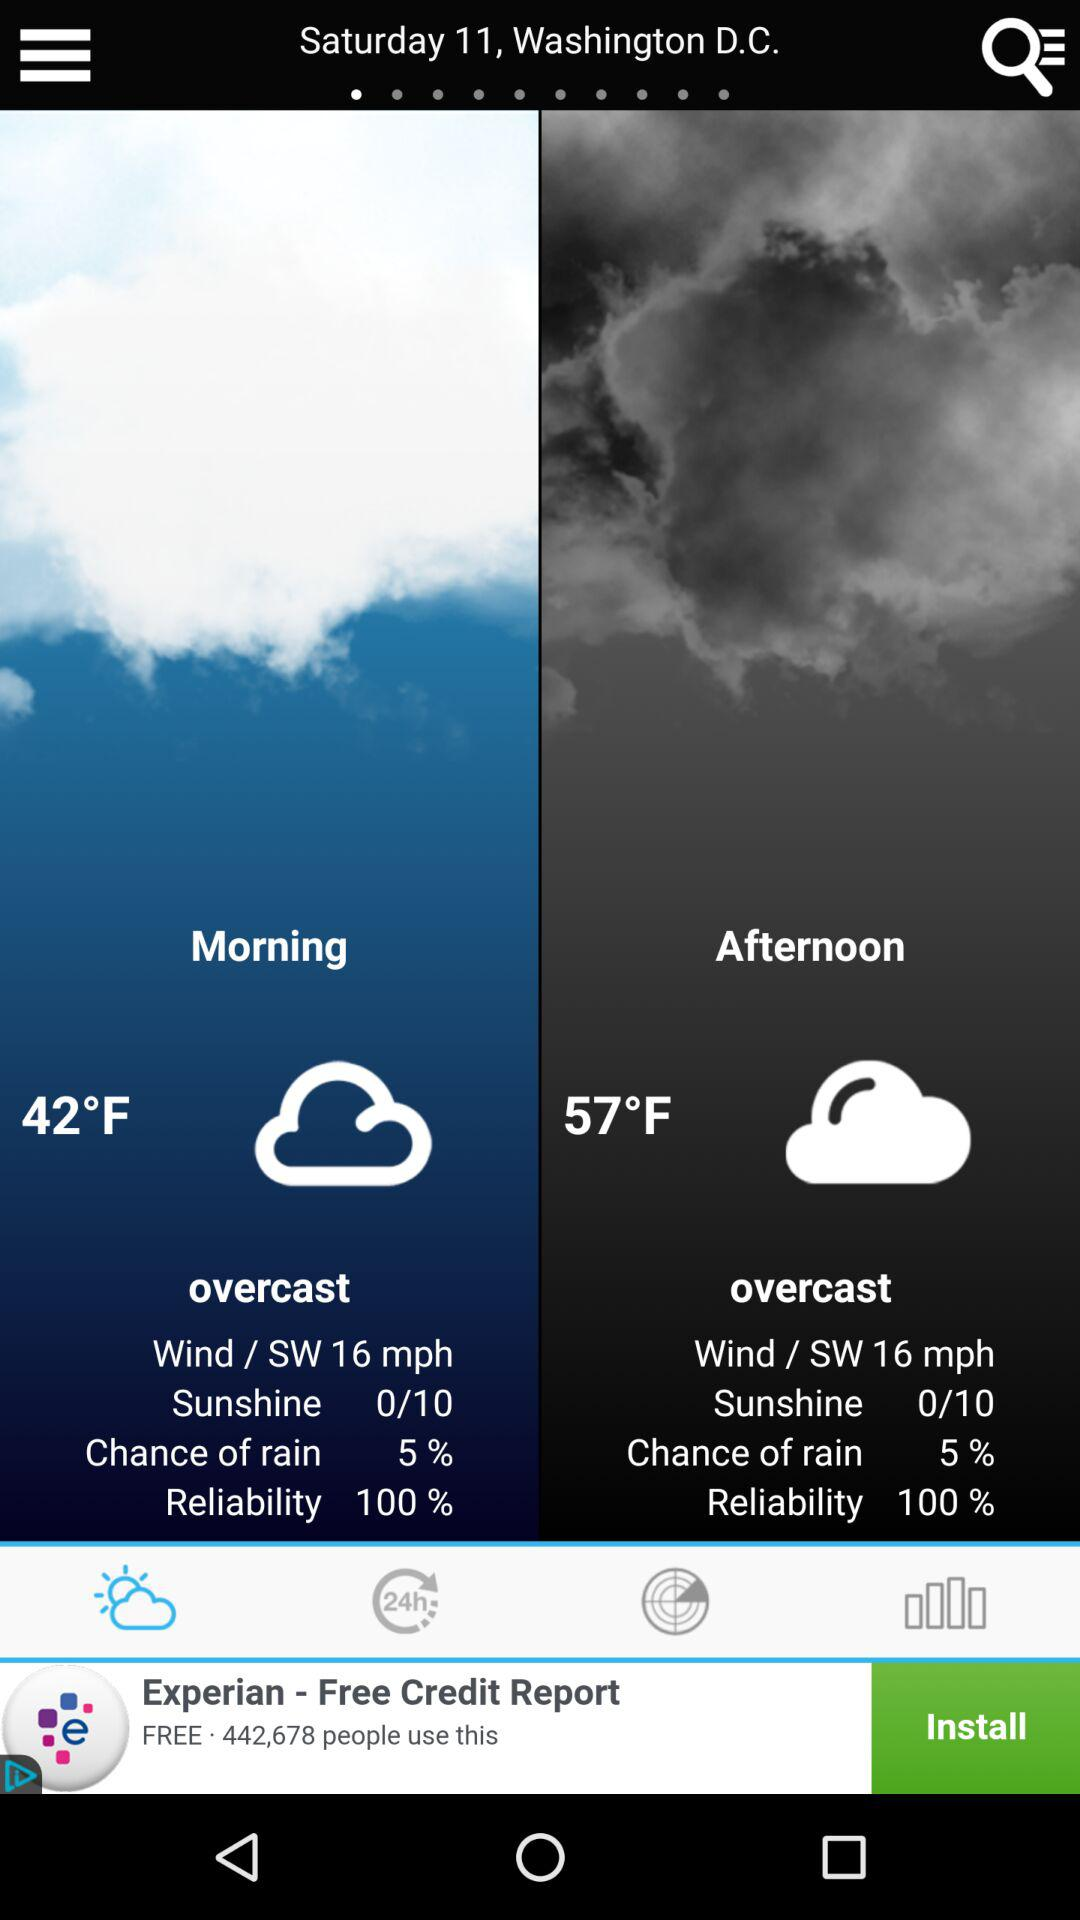What is the difference in temperature between the morning and afternoon?
Answer the question using a single word or phrase. 15°F 